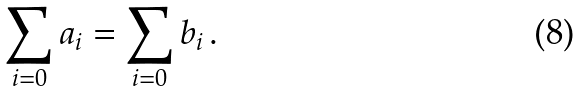Convert formula to latex. <formula><loc_0><loc_0><loc_500><loc_500>\sum _ { i = 0 } a _ { i } & = \sum _ { i = 0 } b _ { i } \, .</formula> 